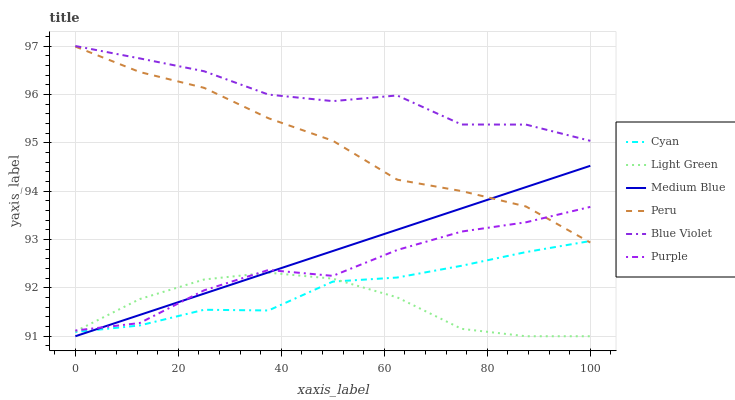Does Light Green have the minimum area under the curve?
Answer yes or no. Yes. Does Blue Violet have the maximum area under the curve?
Answer yes or no. Yes. Does Purple have the minimum area under the curve?
Answer yes or no. No. Does Purple have the maximum area under the curve?
Answer yes or no. No. Is Medium Blue the smoothest?
Answer yes or no. Yes. Is Blue Violet the roughest?
Answer yes or no. Yes. Is Purple the smoothest?
Answer yes or no. No. Is Purple the roughest?
Answer yes or no. No. Does Purple have the lowest value?
Answer yes or no. No. Does Blue Violet have the highest value?
Answer yes or no. Yes. Does Purple have the highest value?
Answer yes or no. No. Is Cyan less than Blue Violet?
Answer yes or no. Yes. Is Blue Violet greater than Peru?
Answer yes or no. Yes. Does Cyan intersect Blue Violet?
Answer yes or no. No. 